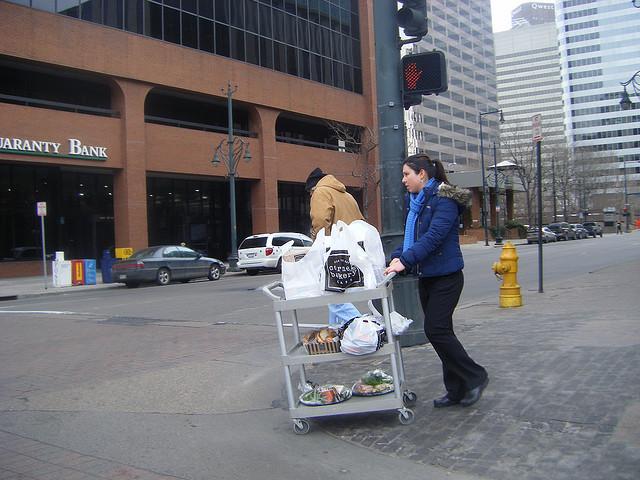What color is the newspaper box on the corner?
Keep it brief. White. Where is the red bottle cap?
Be succinct. Cart. Is this woman outside?
Concise answer only. Yes. What is the man pushing in the cart?
Quick response, please. Food. What color is the fire hydrant?
Concise answer only. Yellow. Who does the lady see coming from a distance?
Give a very brief answer. Car. Is the girl delivering food?
Write a very short answer. Yes. Is this the United States?
Short answer required. Yes. What sort of building is across the street from these people?
Keep it brief. Bank. 